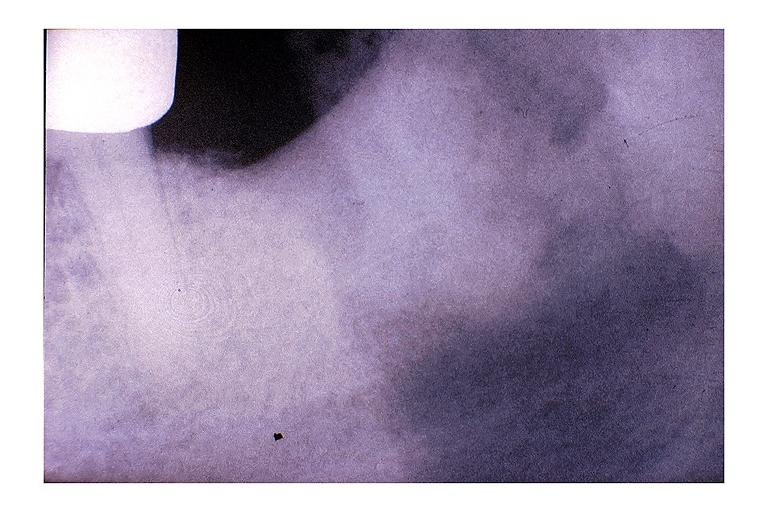where is this?
Answer the question using a single word or phrase. Oral 